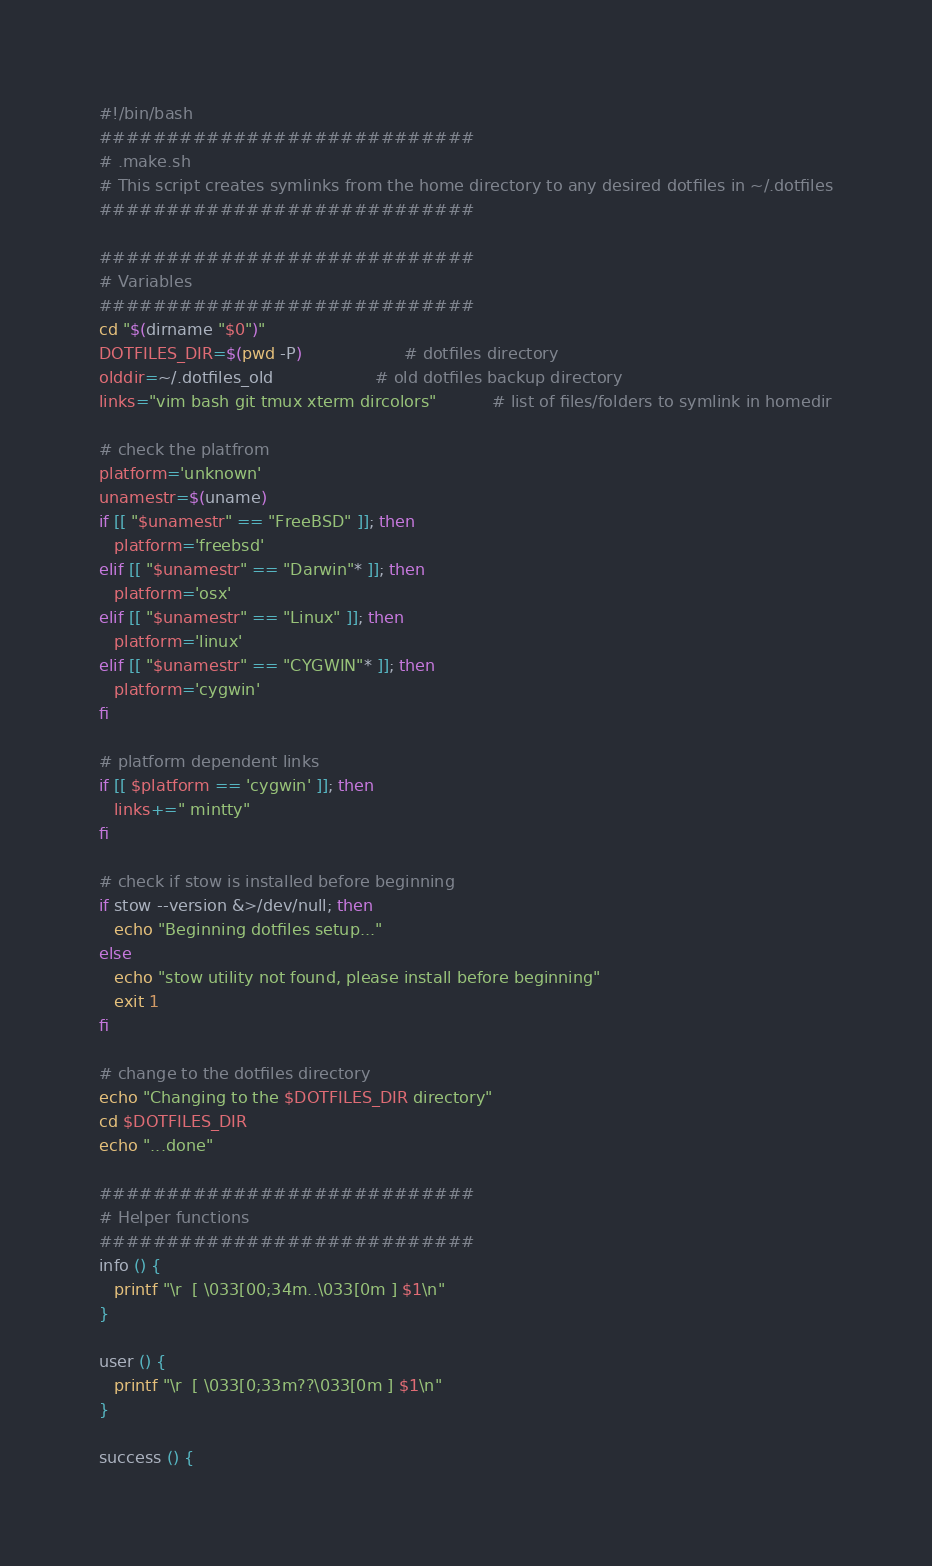Convert code to text. <code><loc_0><loc_0><loc_500><loc_500><_Bash_>#!/bin/bash
############################
# .make.sh
# This script creates symlinks from the home directory to any desired dotfiles in ~/.dotfiles
############################

############################
# Variables
############################
cd "$(dirname "$0")"
DOTFILES_DIR=$(pwd -P)                    # dotfiles directory
olddir=~/.dotfiles_old                    # old dotfiles backup directory
links="vim bash git tmux xterm dircolors"           # list of files/folders to symlink in homedir

# check the platfrom
platform='unknown'
unamestr=$(uname)
if [[ "$unamestr" == "FreeBSD" ]]; then
   platform='freebsd'
elif [[ "$unamestr" == "Darwin"* ]]; then
   platform='osx'
elif [[ "$unamestr" == "Linux" ]]; then
   platform='linux'
elif [[ "$unamestr" == "CYGWIN"* ]]; then
   platform='cygwin'
fi

# platform dependent links
if [[ $platform == 'cygwin' ]]; then
   links+=" mintty"
fi

# check if stow is installed before beginning
if stow --version &>/dev/null; then
   echo "Beginning dotfiles setup..."
else
   echo "stow utility not found, please install before beginning"
   exit 1
fi

# change to the dotfiles directory
echo "Changing to the $DOTFILES_DIR directory"
cd $DOTFILES_DIR
echo "...done"

############################
# Helper functions
############################
info () {
   printf "\r  [ \033[00;34m..\033[0m ] $1\n"
}

user () {
   printf "\r  [ \033[0;33m??\033[0m ] $1\n"
}

success () {</code> 